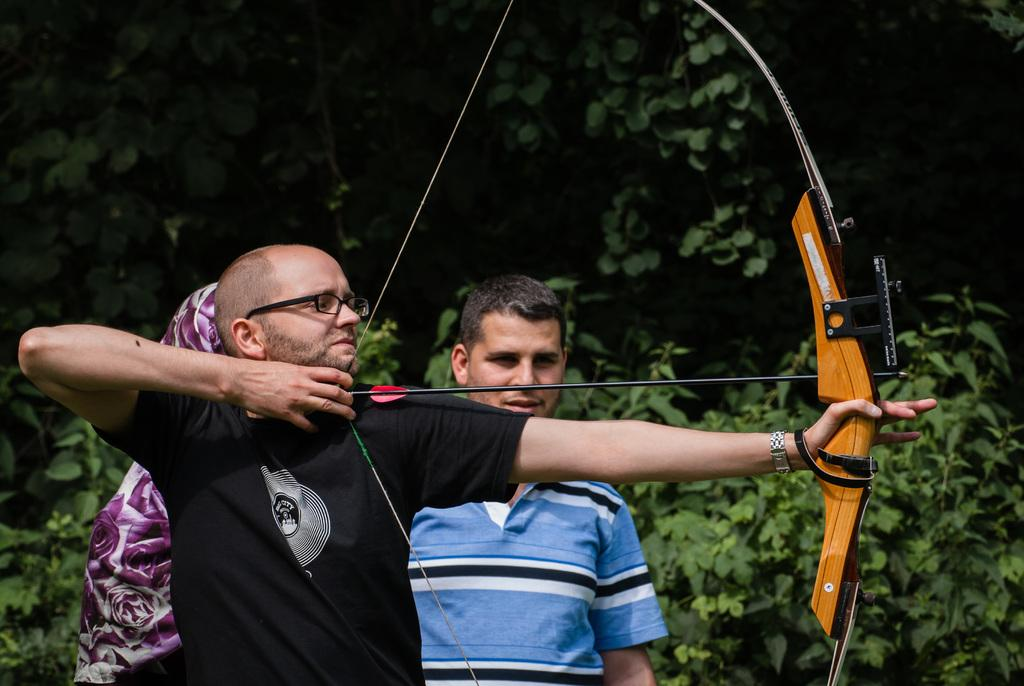What is the main subject in the foreground of the image? There is a man in the foreground of the image. What is the man holding in his hands? The man is holding a bow and an arrow. How many other people are present in the image? There are two persons standing in the background of the image. What type of environment can be seen in the background? There is greenery visible in the background of the image. What type of punishment is being administered to the man in the image? There is no indication of punishment in the image; the man is holding a bow and an arrow, which suggests he might be engaged in archery or hunting. What is the source of the smoke in the image? There is no smoke present in the image. 